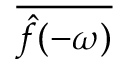Convert formula to latex. <formula><loc_0><loc_0><loc_500><loc_500>\overline { { { \hat { f } } ( - \omega ) } }</formula> 